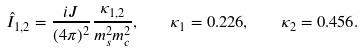Convert formula to latex. <formula><loc_0><loc_0><loc_500><loc_500>\hat { I } _ { 1 , 2 } = \frac { i J } { ( 4 \pi ) ^ { 2 } } \frac { \kappa _ { 1 , 2 } } { m _ { s } ^ { 2 } m _ { c } ^ { 2 } } , \quad \kappa _ { 1 } = 0 . 2 2 6 , \quad \kappa _ { 2 } = 0 . 4 5 6 .</formula> 